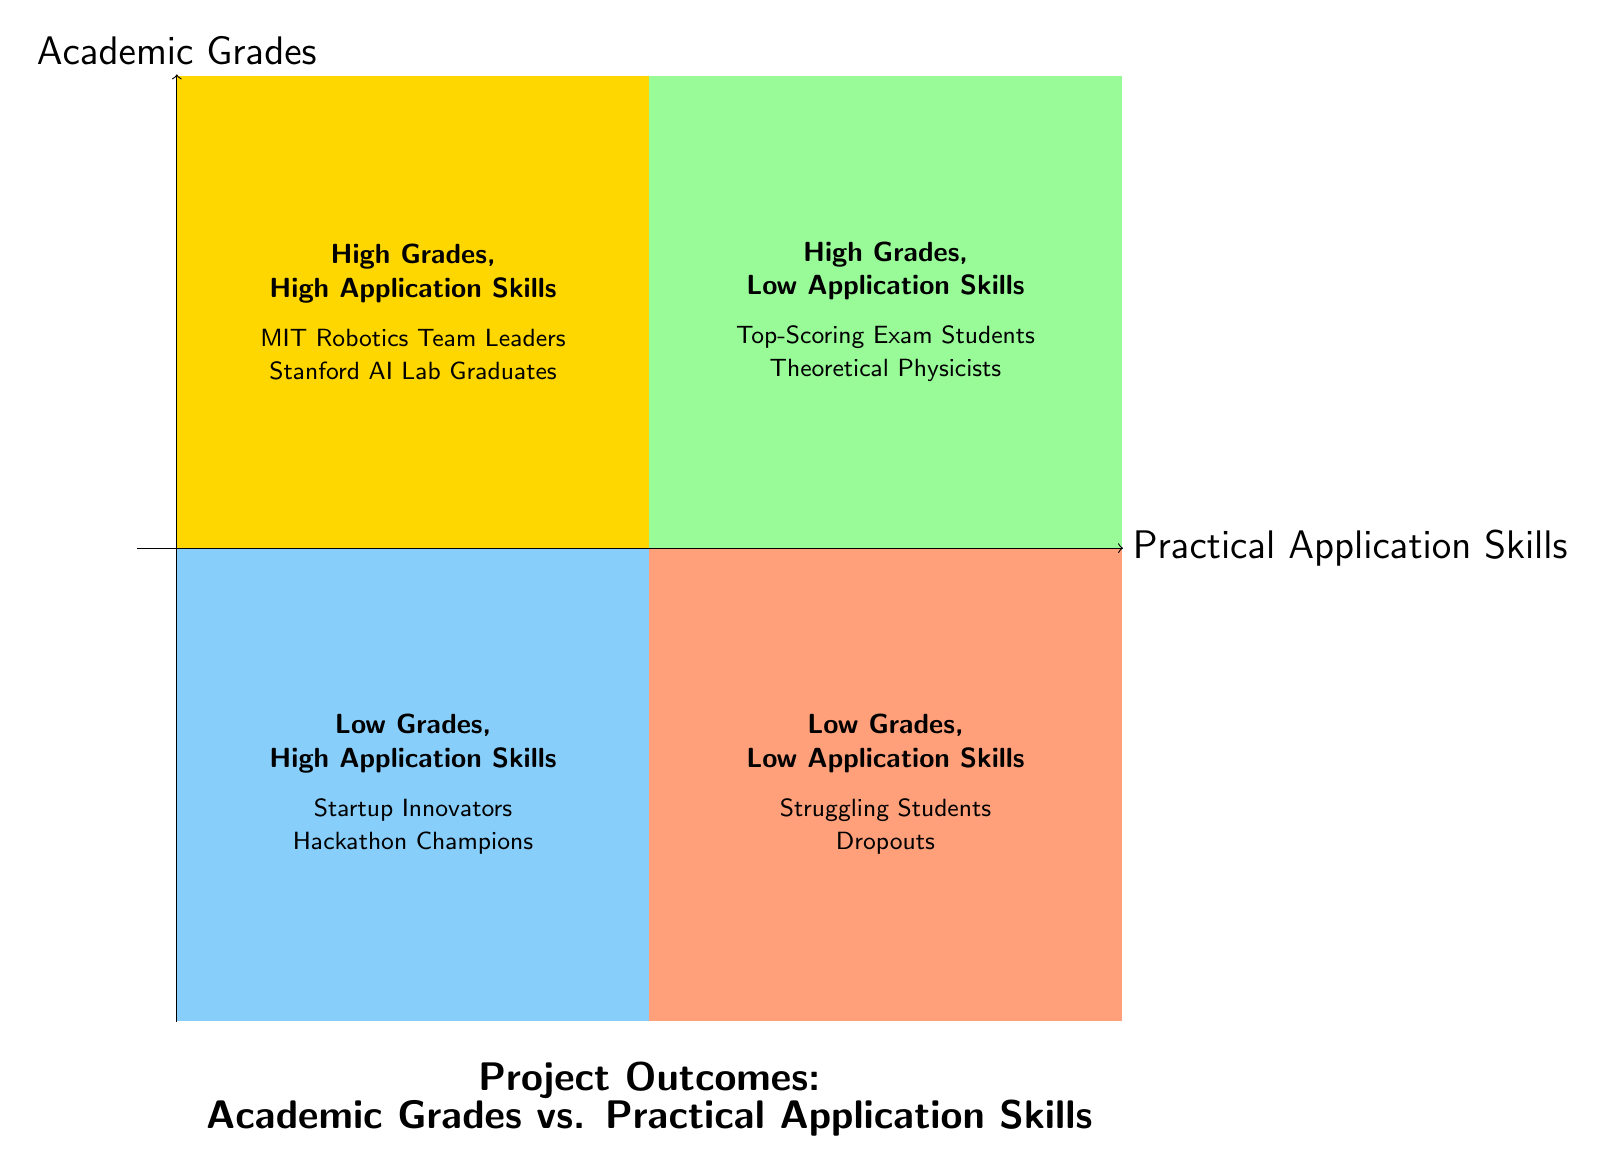What are the two types of project outcomes represented in the quadrants? The quadrants specifically show "Academic Grades vs. Practical Application Skills" on the y-axis and "Collaborative Projects vs. Individual Projects" on the x-axis.
Answer: Academic Grades vs. Practical Application Skills and Collaborative Projects vs. Individual Projects Which group is in the "High Grades, High Application Skills" quadrant? In the quadrant for "High Grades, High Application Skills," the listed groups are "MIT Robotics Team Leaders" and "Stanford AI Lab Graduates."
Answer: MIT Robotics Team Leaders and Stanford AI Lab Graduates How many total groups are identified in the quadrant for "Low Grades, High Application Skills"? There are two groups listed in the "Low Grades, High Application Skills" quadrant, which are "Startup Innovators" and "Hackathon Champions."
Answer: 2 In which quadrant would you find "Large Corporate Teams with Poor Cohesion"? "Large Corporate Teams with Poor Cohesion" is classified in the "High Collaboration, Low Success" quadrant, where collaboration is high but outcomes are not successful.
Answer: High Collaboration, Low Success Which quadrant contains groups associated with low grades? The quadrants that contain groups with low grades are "Low Grades, High Application Skills" and "Low Grades, Low Application Skills."
Answer: Low Grades, High Application Skills and Low Grades, Low Application Skills What can be inferred about groups in the "High Collaboration, High Success" quadrant? Groups in this quadrant, such as "Google X Moonshot Projects" and "NASA Mission Teams," are characterized by high levels of collaboration leading to successful project outcomes.
Answer: High levels of collaboration and success How would you categorize "Isolated Hobbyists" in terms of collaborative projects? "Isolated Hobbyists" fall into the "Low Collaboration, Low Success" quadrant, indicating their lack of collaboration leads to limited successful outcomes.
Answer: Low Collaboration, Low Success 